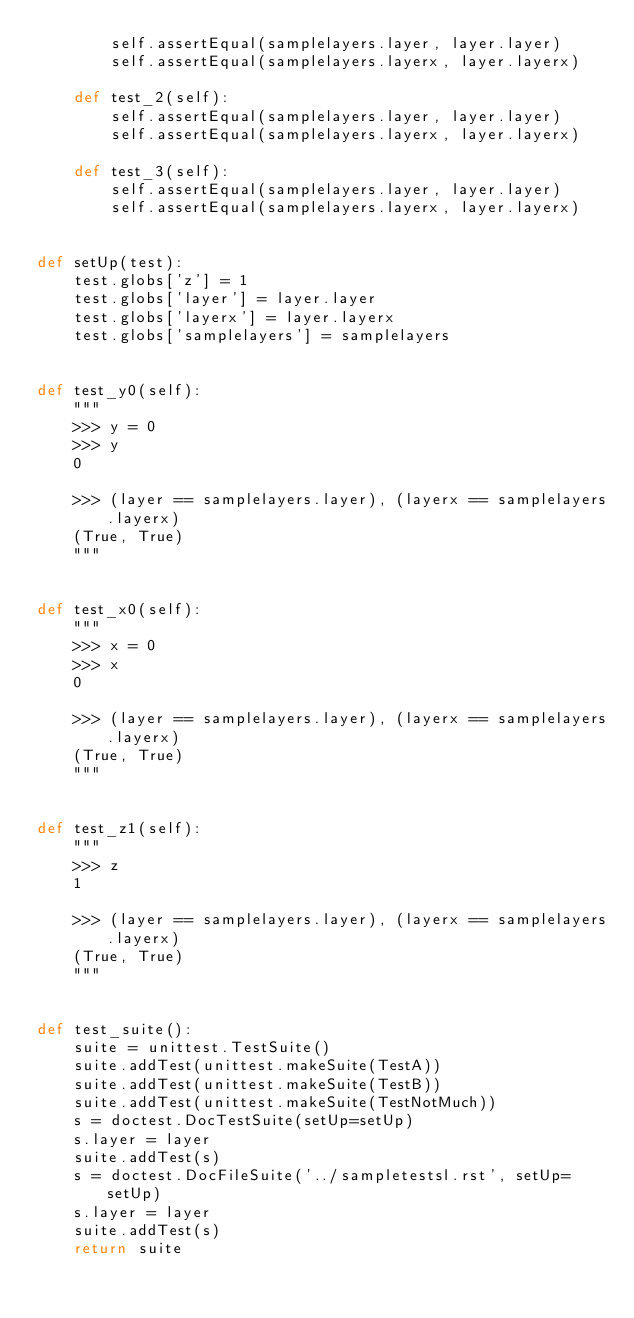<code> <loc_0><loc_0><loc_500><loc_500><_Python_>        self.assertEqual(samplelayers.layer, layer.layer)
        self.assertEqual(samplelayers.layerx, layer.layerx)

    def test_2(self):
        self.assertEqual(samplelayers.layer, layer.layer)
        self.assertEqual(samplelayers.layerx, layer.layerx)

    def test_3(self):
        self.assertEqual(samplelayers.layer, layer.layer)
        self.assertEqual(samplelayers.layerx, layer.layerx)


def setUp(test):
    test.globs['z'] = 1
    test.globs['layer'] = layer.layer
    test.globs['layerx'] = layer.layerx
    test.globs['samplelayers'] = samplelayers


def test_y0(self):
    """
    >>> y = 0
    >>> y
    0

    >>> (layer == samplelayers.layer), (layerx == samplelayers.layerx)
    (True, True)
    """


def test_x0(self):
    """
    >>> x = 0
    >>> x
    0

    >>> (layer == samplelayers.layer), (layerx == samplelayers.layerx)
    (True, True)
    """


def test_z1(self):
    """
    >>> z
    1

    >>> (layer == samplelayers.layer), (layerx == samplelayers.layerx)
    (True, True)
    """


def test_suite():
    suite = unittest.TestSuite()
    suite.addTest(unittest.makeSuite(TestA))
    suite.addTest(unittest.makeSuite(TestB))
    suite.addTest(unittest.makeSuite(TestNotMuch))
    s = doctest.DocTestSuite(setUp=setUp)
    s.layer = layer
    suite.addTest(s)
    s = doctest.DocFileSuite('../sampletestsl.rst', setUp=setUp)
    s.layer = layer
    suite.addTest(s)
    return suite
</code> 